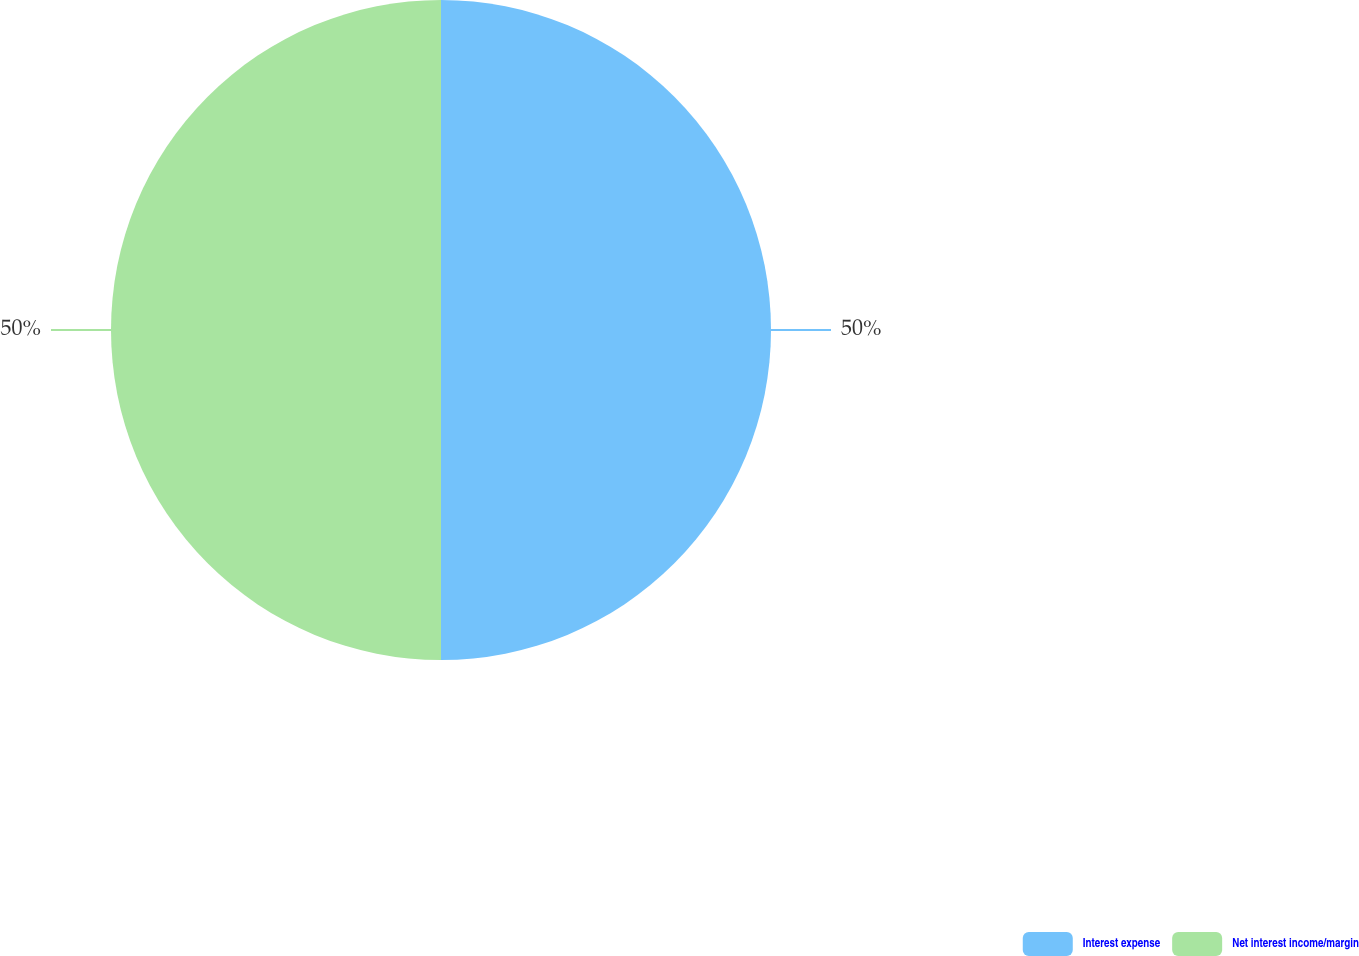Convert chart. <chart><loc_0><loc_0><loc_500><loc_500><pie_chart><fcel>Interest expense<fcel>Net interest income/margin<nl><fcel>50.0%<fcel>50.0%<nl></chart> 